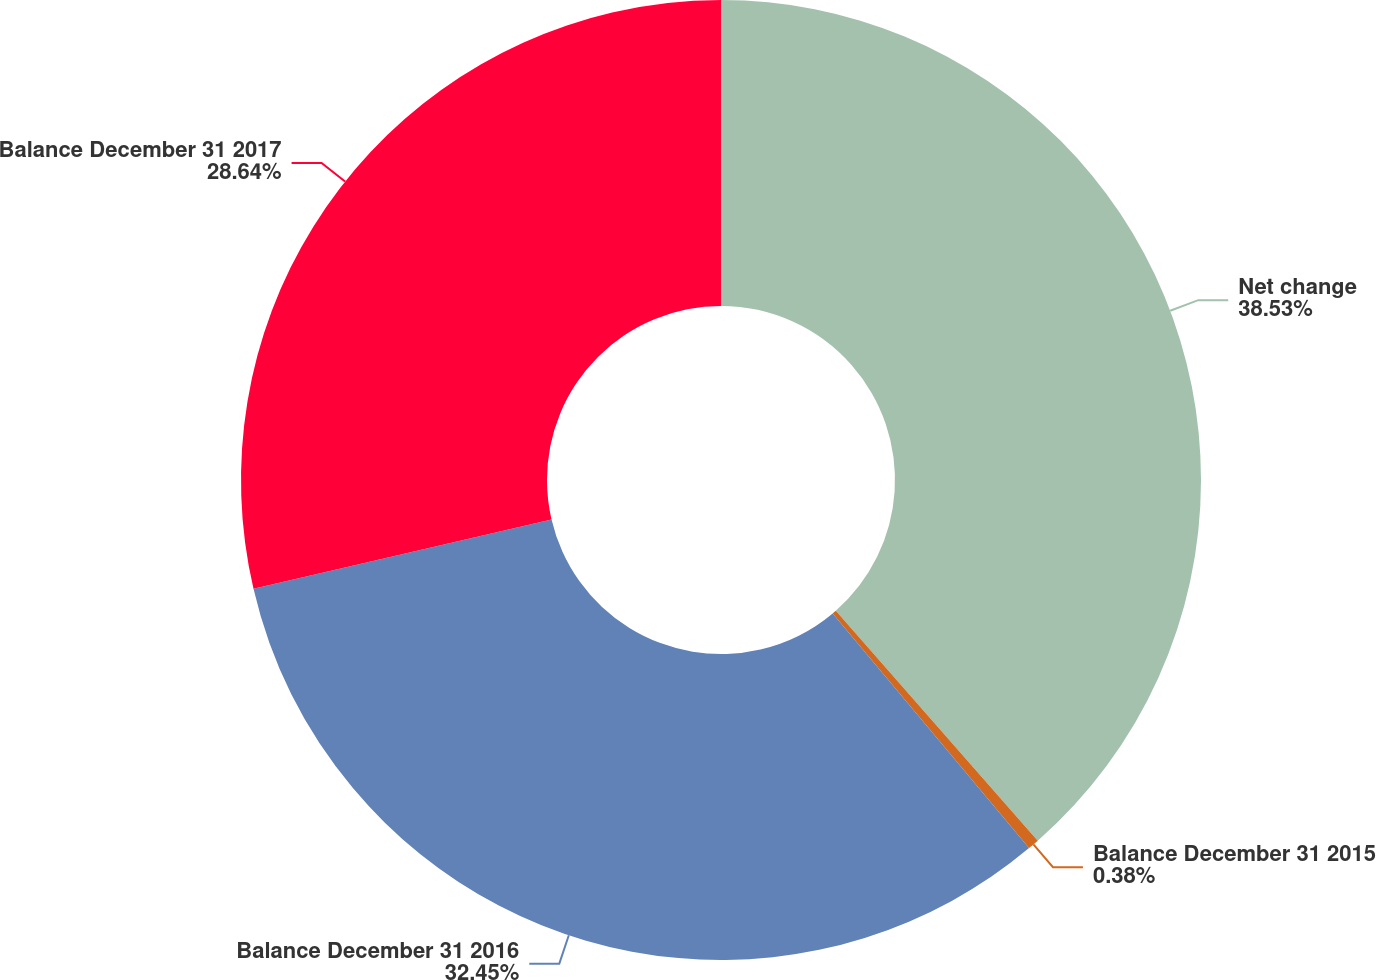Convert chart. <chart><loc_0><loc_0><loc_500><loc_500><pie_chart><fcel>Net change<fcel>Balance December 31 2015<fcel>Balance December 31 2016<fcel>Balance December 31 2017<nl><fcel>38.53%<fcel>0.38%<fcel>32.45%<fcel>28.64%<nl></chart> 